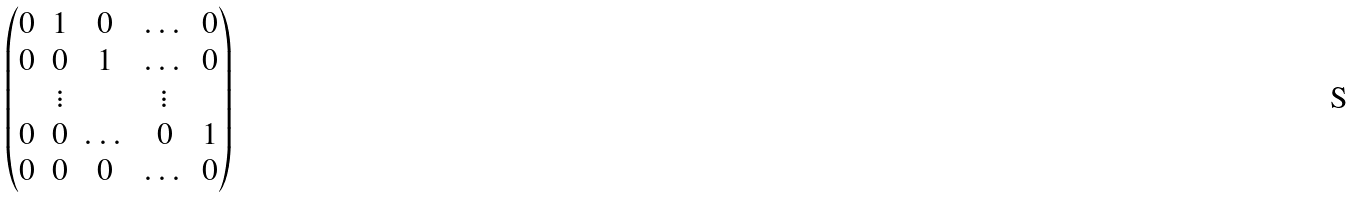<formula> <loc_0><loc_0><loc_500><loc_500>\begin{pmatrix} 0 & 1 & 0 & \dots & 0 \\ 0 & 0 & 1 & \dots & 0 \\ & \vdots & & \vdots & \\ 0 & 0 & \dots & 0 & 1 \\ 0 & 0 & 0 & \dots & 0 \end{pmatrix}</formula> 